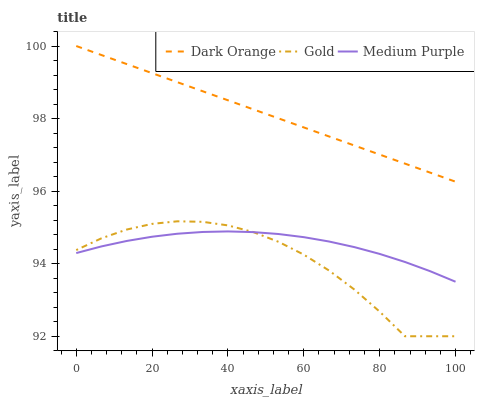Does Gold have the minimum area under the curve?
Answer yes or no. Yes. Does Dark Orange have the maximum area under the curve?
Answer yes or no. Yes. Does Dark Orange have the minimum area under the curve?
Answer yes or no. No. Does Gold have the maximum area under the curve?
Answer yes or no. No. Is Dark Orange the smoothest?
Answer yes or no. Yes. Is Gold the roughest?
Answer yes or no. Yes. Is Gold the smoothest?
Answer yes or no. No. Is Dark Orange the roughest?
Answer yes or no. No. Does Dark Orange have the lowest value?
Answer yes or no. No. Does Gold have the highest value?
Answer yes or no. No. Is Medium Purple less than Dark Orange?
Answer yes or no. Yes. Is Dark Orange greater than Medium Purple?
Answer yes or no. Yes. Does Medium Purple intersect Dark Orange?
Answer yes or no. No. 